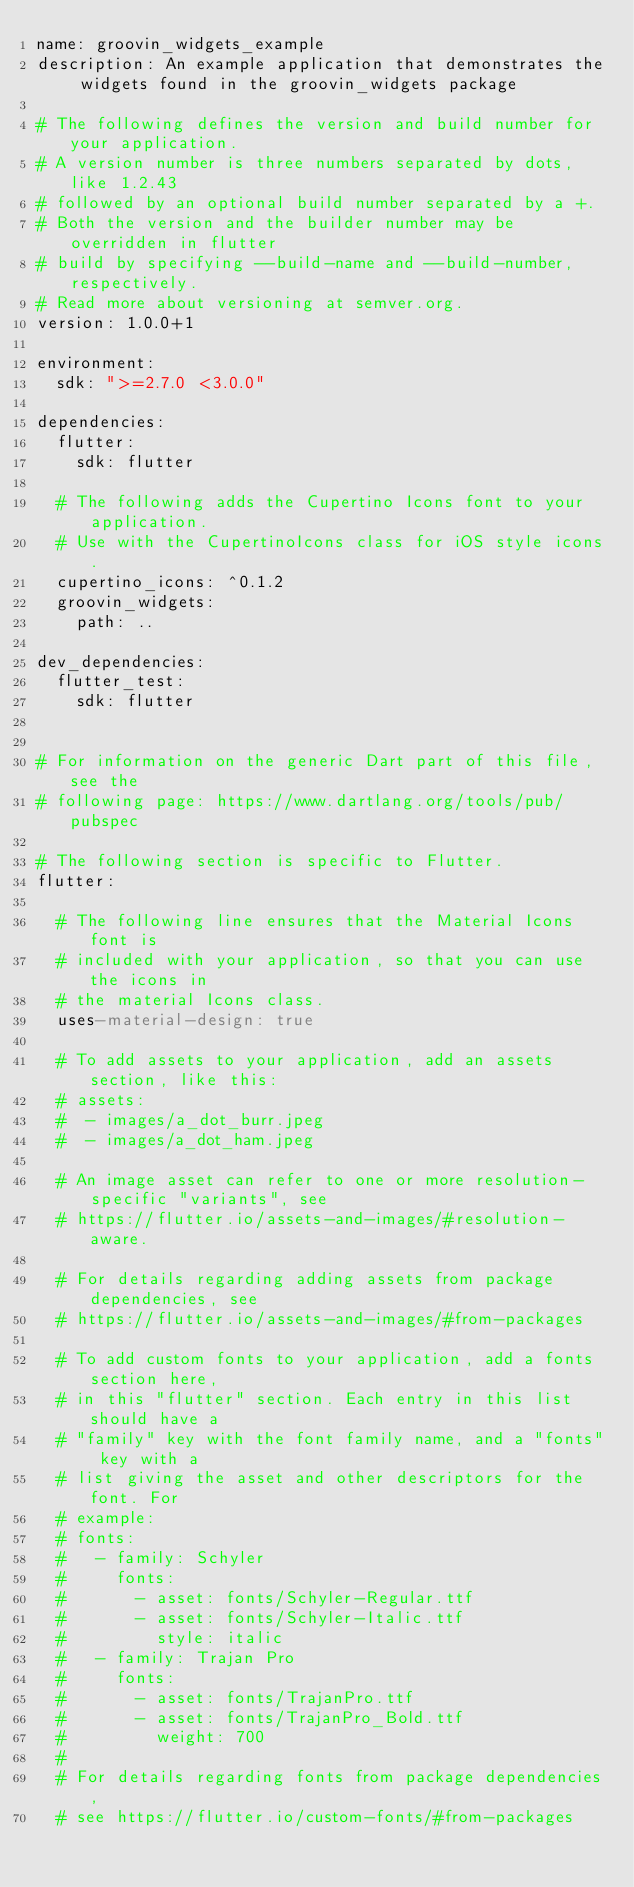Convert code to text. <code><loc_0><loc_0><loc_500><loc_500><_YAML_>name: groovin_widgets_example
description: An example application that demonstrates the widgets found in the groovin_widgets package

# The following defines the version and build number for your application.
# A version number is three numbers separated by dots, like 1.2.43
# followed by an optional build number separated by a +.
# Both the version and the builder number may be overridden in flutter
# build by specifying --build-name and --build-number, respectively.
# Read more about versioning at semver.org.
version: 1.0.0+1

environment:
  sdk: ">=2.7.0 <3.0.0"

dependencies:
  flutter:
    sdk: flutter

  # The following adds the Cupertino Icons font to your application.
  # Use with the CupertinoIcons class for iOS style icons.
  cupertino_icons: ^0.1.2
  groovin_widgets:
    path: ..

dev_dependencies:
  flutter_test:
    sdk: flutter


# For information on the generic Dart part of this file, see the
# following page: https://www.dartlang.org/tools/pub/pubspec

# The following section is specific to Flutter.
flutter:

  # The following line ensures that the Material Icons font is
  # included with your application, so that you can use the icons in
  # the material Icons class.
  uses-material-design: true

  # To add assets to your application, add an assets section, like this:
  # assets:
  #  - images/a_dot_burr.jpeg
  #  - images/a_dot_ham.jpeg

  # An image asset can refer to one or more resolution-specific "variants", see
  # https://flutter.io/assets-and-images/#resolution-aware.

  # For details regarding adding assets from package dependencies, see
  # https://flutter.io/assets-and-images/#from-packages

  # To add custom fonts to your application, add a fonts section here,
  # in this "flutter" section. Each entry in this list should have a
  # "family" key with the font family name, and a "fonts" key with a
  # list giving the asset and other descriptors for the font. For
  # example:
  # fonts:
  #   - family: Schyler
  #     fonts:
  #       - asset: fonts/Schyler-Regular.ttf
  #       - asset: fonts/Schyler-Italic.ttf
  #         style: italic
  #   - family: Trajan Pro
  #     fonts:
  #       - asset: fonts/TrajanPro.ttf
  #       - asset: fonts/TrajanPro_Bold.ttf
  #         weight: 700
  #
  # For details regarding fonts from package dependencies,
  # see https://flutter.io/custom-fonts/#from-packages
</code> 